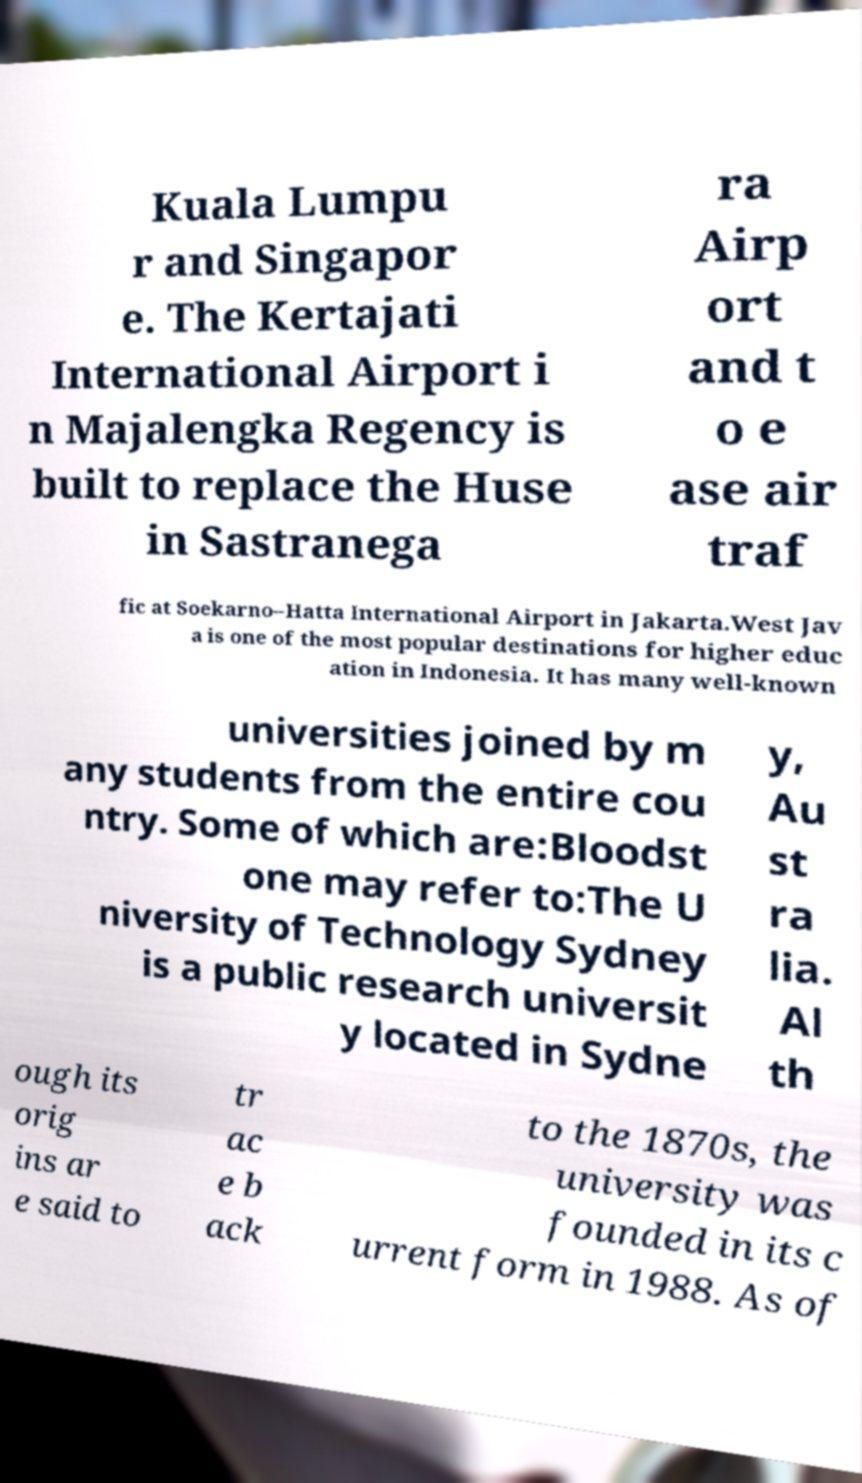There's text embedded in this image that I need extracted. Can you transcribe it verbatim? Kuala Lumpu r and Singapor e. The Kertajati International Airport i n Majalengka Regency is built to replace the Huse in Sastranega ra Airp ort and t o e ase air traf fic at Soekarno–Hatta International Airport in Jakarta.West Jav a is one of the most popular destinations for higher educ ation in Indonesia. It has many well-known universities joined by m any students from the entire cou ntry. Some of which are:Bloodst one may refer to:The U niversity of Technology Sydney is a public research universit y located in Sydne y, Au st ra lia. Al th ough its orig ins ar e said to tr ac e b ack to the 1870s, the university was founded in its c urrent form in 1988. As of 